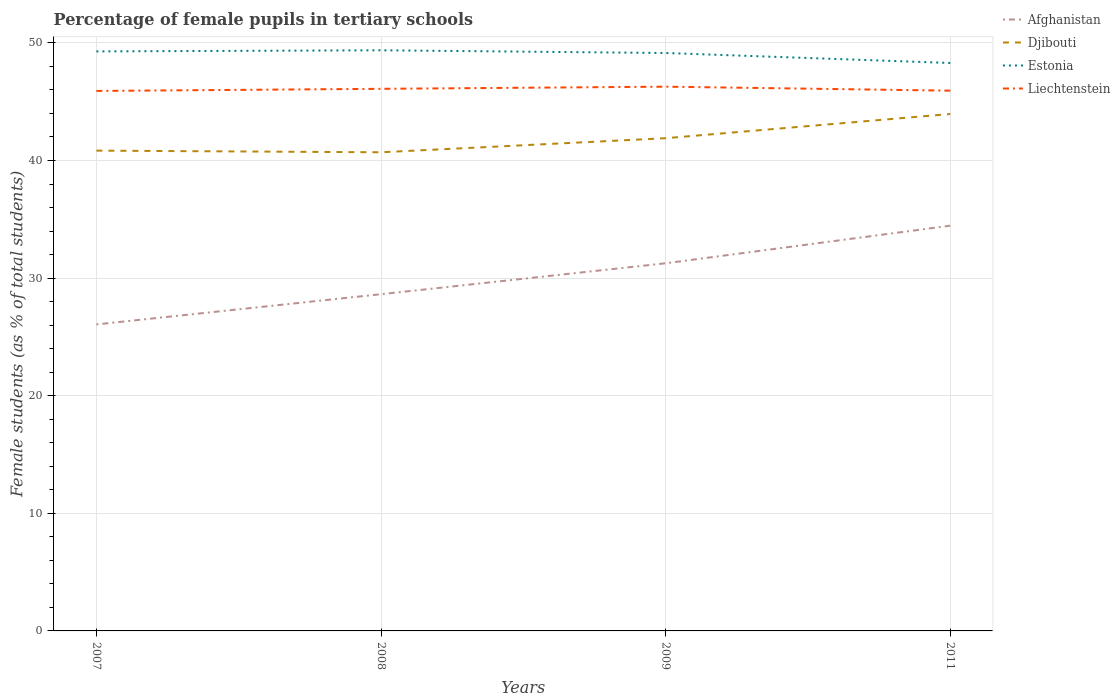How many different coloured lines are there?
Offer a terse response. 4. Across all years, what is the maximum percentage of female pupils in tertiary schools in Afghanistan?
Your response must be concise. 26.06. In which year was the percentage of female pupils in tertiary schools in Liechtenstein maximum?
Your answer should be compact. 2007. What is the total percentage of female pupils in tertiary schools in Djibouti in the graph?
Give a very brief answer. -2.06. What is the difference between the highest and the second highest percentage of female pupils in tertiary schools in Afghanistan?
Ensure brevity in your answer.  8.39. What is the difference between the highest and the lowest percentage of female pupils in tertiary schools in Liechtenstein?
Keep it short and to the point. 2. Is the percentage of female pupils in tertiary schools in Afghanistan strictly greater than the percentage of female pupils in tertiary schools in Estonia over the years?
Your answer should be very brief. Yes. How many lines are there?
Your answer should be very brief. 4. Are the values on the major ticks of Y-axis written in scientific E-notation?
Your answer should be very brief. No. Does the graph contain grids?
Offer a very short reply. Yes. How are the legend labels stacked?
Offer a very short reply. Vertical. What is the title of the graph?
Provide a short and direct response. Percentage of female pupils in tertiary schools. What is the label or title of the Y-axis?
Provide a short and direct response. Female students (as % of total students). What is the Female students (as % of total students) of Afghanistan in 2007?
Ensure brevity in your answer.  26.06. What is the Female students (as % of total students) in Djibouti in 2007?
Ensure brevity in your answer.  40.84. What is the Female students (as % of total students) of Estonia in 2007?
Offer a very short reply. 49.27. What is the Female students (as % of total students) of Liechtenstein in 2007?
Your response must be concise. 45.91. What is the Female students (as % of total students) of Afghanistan in 2008?
Offer a very short reply. 28.63. What is the Female students (as % of total students) of Djibouti in 2008?
Provide a succinct answer. 40.7. What is the Female students (as % of total students) in Estonia in 2008?
Ensure brevity in your answer.  49.37. What is the Female students (as % of total students) in Liechtenstein in 2008?
Ensure brevity in your answer.  46.09. What is the Female students (as % of total students) of Afghanistan in 2009?
Your answer should be compact. 31.26. What is the Female students (as % of total students) of Djibouti in 2009?
Your answer should be very brief. 41.89. What is the Female students (as % of total students) of Estonia in 2009?
Give a very brief answer. 49.14. What is the Female students (as % of total students) of Liechtenstein in 2009?
Ensure brevity in your answer.  46.28. What is the Female students (as % of total students) in Afghanistan in 2011?
Offer a very short reply. 34.46. What is the Female students (as % of total students) in Djibouti in 2011?
Give a very brief answer. 43.95. What is the Female students (as % of total students) in Estonia in 2011?
Ensure brevity in your answer.  48.29. What is the Female students (as % of total students) in Liechtenstein in 2011?
Offer a terse response. 45.94. Across all years, what is the maximum Female students (as % of total students) of Afghanistan?
Offer a terse response. 34.46. Across all years, what is the maximum Female students (as % of total students) of Djibouti?
Provide a succinct answer. 43.95. Across all years, what is the maximum Female students (as % of total students) in Estonia?
Your response must be concise. 49.37. Across all years, what is the maximum Female students (as % of total students) of Liechtenstein?
Keep it short and to the point. 46.28. Across all years, what is the minimum Female students (as % of total students) of Afghanistan?
Your answer should be compact. 26.06. Across all years, what is the minimum Female students (as % of total students) of Djibouti?
Offer a terse response. 40.7. Across all years, what is the minimum Female students (as % of total students) of Estonia?
Your response must be concise. 48.29. Across all years, what is the minimum Female students (as % of total students) of Liechtenstein?
Your answer should be compact. 45.91. What is the total Female students (as % of total students) in Afghanistan in the graph?
Your answer should be very brief. 120.41. What is the total Female students (as % of total students) in Djibouti in the graph?
Make the answer very short. 167.38. What is the total Female students (as % of total students) of Estonia in the graph?
Ensure brevity in your answer.  196.08. What is the total Female students (as % of total students) in Liechtenstein in the graph?
Your answer should be very brief. 184.22. What is the difference between the Female students (as % of total students) in Afghanistan in 2007 and that in 2008?
Ensure brevity in your answer.  -2.57. What is the difference between the Female students (as % of total students) of Djibouti in 2007 and that in 2008?
Ensure brevity in your answer.  0.14. What is the difference between the Female students (as % of total students) in Estonia in 2007 and that in 2008?
Your answer should be compact. -0.1. What is the difference between the Female students (as % of total students) of Liechtenstein in 2007 and that in 2008?
Offer a very short reply. -0.18. What is the difference between the Female students (as % of total students) of Afghanistan in 2007 and that in 2009?
Keep it short and to the point. -5.2. What is the difference between the Female students (as % of total students) in Djibouti in 2007 and that in 2009?
Offer a terse response. -1.06. What is the difference between the Female students (as % of total students) in Estonia in 2007 and that in 2009?
Offer a terse response. 0.14. What is the difference between the Female students (as % of total students) in Liechtenstein in 2007 and that in 2009?
Your answer should be compact. -0.36. What is the difference between the Female students (as % of total students) of Afghanistan in 2007 and that in 2011?
Provide a short and direct response. -8.39. What is the difference between the Female students (as % of total students) in Djibouti in 2007 and that in 2011?
Provide a short and direct response. -3.12. What is the difference between the Female students (as % of total students) of Estonia in 2007 and that in 2011?
Give a very brief answer. 0.98. What is the difference between the Female students (as % of total students) of Liechtenstein in 2007 and that in 2011?
Offer a terse response. -0.02. What is the difference between the Female students (as % of total students) in Afghanistan in 2008 and that in 2009?
Provide a succinct answer. -2.63. What is the difference between the Female students (as % of total students) of Djibouti in 2008 and that in 2009?
Provide a succinct answer. -1.2. What is the difference between the Female students (as % of total students) in Estonia in 2008 and that in 2009?
Provide a short and direct response. 0.23. What is the difference between the Female students (as % of total students) in Liechtenstein in 2008 and that in 2009?
Give a very brief answer. -0.18. What is the difference between the Female students (as % of total students) of Afghanistan in 2008 and that in 2011?
Ensure brevity in your answer.  -5.83. What is the difference between the Female students (as % of total students) in Djibouti in 2008 and that in 2011?
Your answer should be very brief. -3.26. What is the difference between the Female students (as % of total students) in Estonia in 2008 and that in 2011?
Your answer should be compact. 1.08. What is the difference between the Female students (as % of total students) in Liechtenstein in 2008 and that in 2011?
Your response must be concise. 0.16. What is the difference between the Female students (as % of total students) of Afghanistan in 2009 and that in 2011?
Offer a terse response. -3.2. What is the difference between the Female students (as % of total students) in Djibouti in 2009 and that in 2011?
Keep it short and to the point. -2.06. What is the difference between the Female students (as % of total students) in Estonia in 2009 and that in 2011?
Provide a succinct answer. 0.85. What is the difference between the Female students (as % of total students) in Liechtenstein in 2009 and that in 2011?
Your response must be concise. 0.34. What is the difference between the Female students (as % of total students) of Afghanistan in 2007 and the Female students (as % of total students) of Djibouti in 2008?
Offer a terse response. -14.64. What is the difference between the Female students (as % of total students) in Afghanistan in 2007 and the Female students (as % of total students) in Estonia in 2008?
Give a very brief answer. -23.31. What is the difference between the Female students (as % of total students) of Afghanistan in 2007 and the Female students (as % of total students) of Liechtenstein in 2008?
Give a very brief answer. -20.03. What is the difference between the Female students (as % of total students) in Djibouti in 2007 and the Female students (as % of total students) in Estonia in 2008?
Your response must be concise. -8.53. What is the difference between the Female students (as % of total students) of Djibouti in 2007 and the Female students (as % of total students) of Liechtenstein in 2008?
Keep it short and to the point. -5.26. What is the difference between the Female students (as % of total students) in Estonia in 2007 and the Female students (as % of total students) in Liechtenstein in 2008?
Your response must be concise. 3.18. What is the difference between the Female students (as % of total students) of Afghanistan in 2007 and the Female students (as % of total students) of Djibouti in 2009?
Give a very brief answer. -15.83. What is the difference between the Female students (as % of total students) in Afghanistan in 2007 and the Female students (as % of total students) in Estonia in 2009?
Give a very brief answer. -23.08. What is the difference between the Female students (as % of total students) in Afghanistan in 2007 and the Female students (as % of total students) in Liechtenstein in 2009?
Your response must be concise. -20.22. What is the difference between the Female students (as % of total students) in Djibouti in 2007 and the Female students (as % of total students) in Estonia in 2009?
Provide a succinct answer. -8.3. What is the difference between the Female students (as % of total students) in Djibouti in 2007 and the Female students (as % of total students) in Liechtenstein in 2009?
Offer a very short reply. -5.44. What is the difference between the Female students (as % of total students) of Estonia in 2007 and the Female students (as % of total students) of Liechtenstein in 2009?
Your response must be concise. 3. What is the difference between the Female students (as % of total students) in Afghanistan in 2007 and the Female students (as % of total students) in Djibouti in 2011?
Your response must be concise. -17.89. What is the difference between the Female students (as % of total students) in Afghanistan in 2007 and the Female students (as % of total students) in Estonia in 2011?
Provide a short and direct response. -22.23. What is the difference between the Female students (as % of total students) of Afghanistan in 2007 and the Female students (as % of total students) of Liechtenstein in 2011?
Offer a terse response. -19.88. What is the difference between the Female students (as % of total students) of Djibouti in 2007 and the Female students (as % of total students) of Estonia in 2011?
Provide a succinct answer. -7.45. What is the difference between the Female students (as % of total students) in Djibouti in 2007 and the Female students (as % of total students) in Liechtenstein in 2011?
Provide a succinct answer. -5.1. What is the difference between the Female students (as % of total students) of Estonia in 2007 and the Female students (as % of total students) of Liechtenstein in 2011?
Ensure brevity in your answer.  3.34. What is the difference between the Female students (as % of total students) in Afghanistan in 2008 and the Female students (as % of total students) in Djibouti in 2009?
Keep it short and to the point. -13.26. What is the difference between the Female students (as % of total students) in Afghanistan in 2008 and the Female students (as % of total students) in Estonia in 2009?
Give a very brief answer. -20.51. What is the difference between the Female students (as % of total students) in Afghanistan in 2008 and the Female students (as % of total students) in Liechtenstein in 2009?
Give a very brief answer. -17.65. What is the difference between the Female students (as % of total students) in Djibouti in 2008 and the Female students (as % of total students) in Estonia in 2009?
Keep it short and to the point. -8.44. What is the difference between the Female students (as % of total students) in Djibouti in 2008 and the Female students (as % of total students) in Liechtenstein in 2009?
Keep it short and to the point. -5.58. What is the difference between the Female students (as % of total students) of Estonia in 2008 and the Female students (as % of total students) of Liechtenstein in 2009?
Your response must be concise. 3.09. What is the difference between the Female students (as % of total students) in Afghanistan in 2008 and the Female students (as % of total students) in Djibouti in 2011?
Offer a terse response. -15.32. What is the difference between the Female students (as % of total students) of Afghanistan in 2008 and the Female students (as % of total students) of Estonia in 2011?
Provide a succinct answer. -19.66. What is the difference between the Female students (as % of total students) of Afghanistan in 2008 and the Female students (as % of total students) of Liechtenstein in 2011?
Provide a short and direct response. -17.31. What is the difference between the Female students (as % of total students) in Djibouti in 2008 and the Female students (as % of total students) in Estonia in 2011?
Your answer should be very brief. -7.59. What is the difference between the Female students (as % of total students) in Djibouti in 2008 and the Female students (as % of total students) in Liechtenstein in 2011?
Provide a short and direct response. -5.24. What is the difference between the Female students (as % of total students) in Estonia in 2008 and the Female students (as % of total students) in Liechtenstein in 2011?
Make the answer very short. 3.43. What is the difference between the Female students (as % of total students) of Afghanistan in 2009 and the Female students (as % of total students) of Djibouti in 2011?
Your answer should be very brief. -12.69. What is the difference between the Female students (as % of total students) of Afghanistan in 2009 and the Female students (as % of total students) of Estonia in 2011?
Keep it short and to the point. -17.03. What is the difference between the Female students (as % of total students) in Afghanistan in 2009 and the Female students (as % of total students) in Liechtenstein in 2011?
Give a very brief answer. -14.68. What is the difference between the Female students (as % of total students) in Djibouti in 2009 and the Female students (as % of total students) in Estonia in 2011?
Your response must be concise. -6.4. What is the difference between the Female students (as % of total students) in Djibouti in 2009 and the Female students (as % of total students) in Liechtenstein in 2011?
Keep it short and to the point. -4.04. What is the difference between the Female students (as % of total students) in Estonia in 2009 and the Female students (as % of total students) in Liechtenstein in 2011?
Your answer should be very brief. 3.2. What is the average Female students (as % of total students) of Afghanistan per year?
Offer a terse response. 30.1. What is the average Female students (as % of total students) of Djibouti per year?
Make the answer very short. 41.85. What is the average Female students (as % of total students) in Estonia per year?
Offer a very short reply. 49.02. What is the average Female students (as % of total students) of Liechtenstein per year?
Make the answer very short. 46.06. In the year 2007, what is the difference between the Female students (as % of total students) in Afghanistan and Female students (as % of total students) in Djibouti?
Provide a succinct answer. -14.78. In the year 2007, what is the difference between the Female students (as % of total students) of Afghanistan and Female students (as % of total students) of Estonia?
Make the answer very short. -23.21. In the year 2007, what is the difference between the Female students (as % of total students) in Afghanistan and Female students (as % of total students) in Liechtenstein?
Give a very brief answer. -19.85. In the year 2007, what is the difference between the Female students (as % of total students) in Djibouti and Female students (as % of total students) in Estonia?
Offer a terse response. -8.44. In the year 2007, what is the difference between the Female students (as % of total students) in Djibouti and Female students (as % of total students) in Liechtenstein?
Offer a terse response. -5.08. In the year 2007, what is the difference between the Female students (as % of total students) in Estonia and Female students (as % of total students) in Liechtenstein?
Offer a very short reply. 3.36. In the year 2008, what is the difference between the Female students (as % of total students) in Afghanistan and Female students (as % of total students) in Djibouti?
Offer a very short reply. -12.07. In the year 2008, what is the difference between the Female students (as % of total students) in Afghanistan and Female students (as % of total students) in Estonia?
Your response must be concise. -20.74. In the year 2008, what is the difference between the Female students (as % of total students) of Afghanistan and Female students (as % of total students) of Liechtenstein?
Ensure brevity in your answer.  -17.46. In the year 2008, what is the difference between the Female students (as % of total students) of Djibouti and Female students (as % of total students) of Estonia?
Give a very brief answer. -8.67. In the year 2008, what is the difference between the Female students (as % of total students) of Djibouti and Female students (as % of total students) of Liechtenstein?
Your answer should be compact. -5.4. In the year 2008, what is the difference between the Female students (as % of total students) in Estonia and Female students (as % of total students) in Liechtenstein?
Make the answer very short. 3.28. In the year 2009, what is the difference between the Female students (as % of total students) of Afghanistan and Female students (as % of total students) of Djibouti?
Provide a succinct answer. -10.63. In the year 2009, what is the difference between the Female students (as % of total students) of Afghanistan and Female students (as % of total students) of Estonia?
Offer a terse response. -17.88. In the year 2009, what is the difference between the Female students (as % of total students) of Afghanistan and Female students (as % of total students) of Liechtenstein?
Give a very brief answer. -15.02. In the year 2009, what is the difference between the Female students (as % of total students) of Djibouti and Female students (as % of total students) of Estonia?
Offer a terse response. -7.24. In the year 2009, what is the difference between the Female students (as % of total students) in Djibouti and Female students (as % of total students) in Liechtenstein?
Ensure brevity in your answer.  -4.38. In the year 2009, what is the difference between the Female students (as % of total students) in Estonia and Female students (as % of total students) in Liechtenstein?
Ensure brevity in your answer.  2.86. In the year 2011, what is the difference between the Female students (as % of total students) in Afghanistan and Female students (as % of total students) in Djibouti?
Offer a terse response. -9.5. In the year 2011, what is the difference between the Female students (as % of total students) in Afghanistan and Female students (as % of total students) in Estonia?
Provide a short and direct response. -13.83. In the year 2011, what is the difference between the Female students (as % of total students) in Afghanistan and Female students (as % of total students) in Liechtenstein?
Your answer should be compact. -11.48. In the year 2011, what is the difference between the Female students (as % of total students) of Djibouti and Female students (as % of total students) of Estonia?
Keep it short and to the point. -4.34. In the year 2011, what is the difference between the Female students (as % of total students) of Djibouti and Female students (as % of total students) of Liechtenstein?
Your answer should be compact. -1.98. In the year 2011, what is the difference between the Female students (as % of total students) in Estonia and Female students (as % of total students) in Liechtenstein?
Keep it short and to the point. 2.35. What is the ratio of the Female students (as % of total students) in Afghanistan in 2007 to that in 2008?
Your answer should be compact. 0.91. What is the ratio of the Female students (as % of total students) in Afghanistan in 2007 to that in 2009?
Provide a succinct answer. 0.83. What is the ratio of the Female students (as % of total students) of Djibouti in 2007 to that in 2009?
Offer a very short reply. 0.97. What is the ratio of the Female students (as % of total students) of Estonia in 2007 to that in 2009?
Give a very brief answer. 1. What is the ratio of the Female students (as % of total students) in Afghanistan in 2007 to that in 2011?
Provide a succinct answer. 0.76. What is the ratio of the Female students (as % of total students) in Djibouti in 2007 to that in 2011?
Offer a terse response. 0.93. What is the ratio of the Female students (as % of total students) in Estonia in 2007 to that in 2011?
Keep it short and to the point. 1.02. What is the ratio of the Female students (as % of total students) of Liechtenstein in 2007 to that in 2011?
Give a very brief answer. 1. What is the ratio of the Female students (as % of total students) in Afghanistan in 2008 to that in 2009?
Offer a very short reply. 0.92. What is the ratio of the Female students (as % of total students) in Djibouti in 2008 to that in 2009?
Provide a short and direct response. 0.97. What is the ratio of the Female students (as % of total students) of Liechtenstein in 2008 to that in 2009?
Offer a very short reply. 1. What is the ratio of the Female students (as % of total students) in Afghanistan in 2008 to that in 2011?
Offer a terse response. 0.83. What is the ratio of the Female students (as % of total students) of Djibouti in 2008 to that in 2011?
Provide a succinct answer. 0.93. What is the ratio of the Female students (as % of total students) of Estonia in 2008 to that in 2011?
Your answer should be compact. 1.02. What is the ratio of the Female students (as % of total students) in Afghanistan in 2009 to that in 2011?
Offer a terse response. 0.91. What is the ratio of the Female students (as % of total students) of Djibouti in 2009 to that in 2011?
Your answer should be very brief. 0.95. What is the ratio of the Female students (as % of total students) of Estonia in 2009 to that in 2011?
Ensure brevity in your answer.  1.02. What is the ratio of the Female students (as % of total students) in Liechtenstein in 2009 to that in 2011?
Keep it short and to the point. 1.01. What is the difference between the highest and the second highest Female students (as % of total students) of Afghanistan?
Give a very brief answer. 3.2. What is the difference between the highest and the second highest Female students (as % of total students) in Djibouti?
Your response must be concise. 2.06. What is the difference between the highest and the second highest Female students (as % of total students) in Estonia?
Offer a terse response. 0.1. What is the difference between the highest and the second highest Female students (as % of total students) of Liechtenstein?
Keep it short and to the point. 0.18. What is the difference between the highest and the lowest Female students (as % of total students) of Afghanistan?
Give a very brief answer. 8.39. What is the difference between the highest and the lowest Female students (as % of total students) of Djibouti?
Make the answer very short. 3.26. What is the difference between the highest and the lowest Female students (as % of total students) of Estonia?
Provide a short and direct response. 1.08. What is the difference between the highest and the lowest Female students (as % of total students) of Liechtenstein?
Provide a succinct answer. 0.36. 